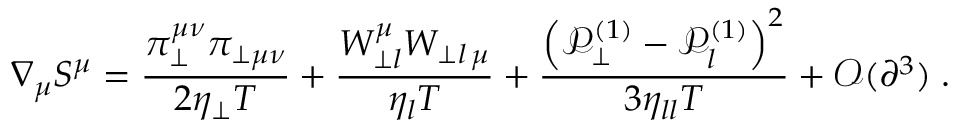Convert formula to latex. <formula><loc_0><loc_0><loc_500><loc_500>\nabla _ { \mu } S ^ { \mu } = \frac { \pi _ { \perp } ^ { \mu \nu } \pi _ { \perp \mu \nu } } { 2 \eta _ { \perp } T } + \frac { W _ { \perp l } ^ { \mu } W _ { \perp l \, \mu } } { \eta _ { l } T } + \frac { \left ( \mathcal { P } _ { \perp } ^ { ( 1 ) } - \mathcal { P } _ { l } ^ { ( 1 ) } \right ) ^ { 2 } } { 3 \eta _ { l l } T } + \mathcal { O } ( \partial ^ { 3 } ) \, .</formula> 